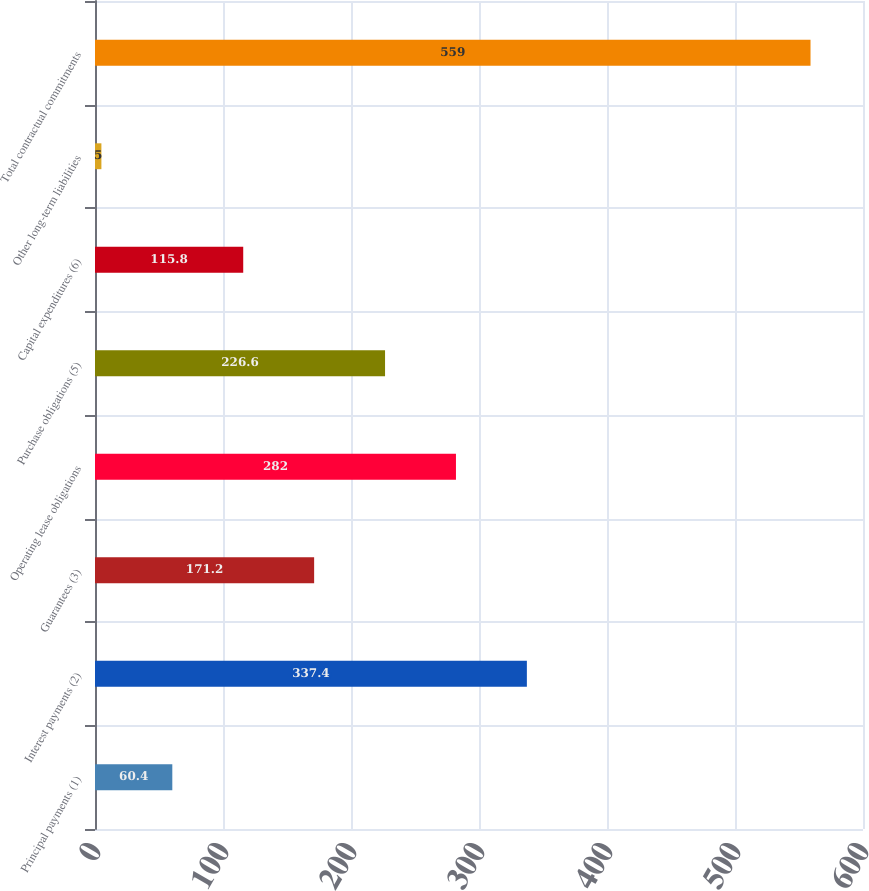<chart> <loc_0><loc_0><loc_500><loc_500><bar_chart><fcel>Principal payments (1)<fcel>Interest payments (2)<fcel>Guarantees (3)<fcel>Operating lease obligations<fcel>Purchase obligations (5)<fcel>Capital expenditures (6)<fcel>Other long-term liabilities<fcel>Total contractual commitments<nl><fcel>60.4<fcel>337.4<fcel>171.2<fcel>282<fcel>226.6<fcel>115.8<fcel>5<fcel>559<nl></chart> 